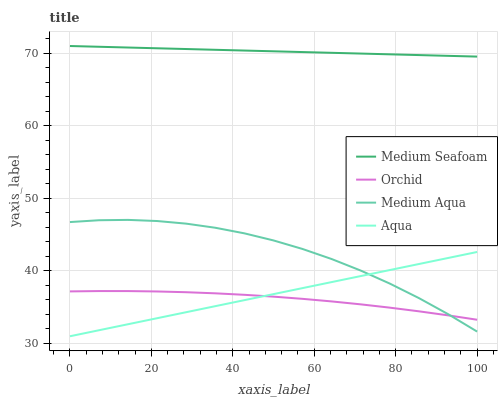Does Orchid have the minimum area under the curve?
Answer yes or no. Yes. Does Medium Seafoam have the maximum area under the curve?
Answer yes or no. Yes. Does Medium Aqua have the minimum area under the curve?
Answer yes or no. No. Does Medium Aqua have the maximum area under the curve?
Answer yes or no. No. Is Aqua the smoothest?
Answer yes or no. Yes. Is Medium Aqua the roughest?
Answer yes or no. Yes. Is Medium Seafoam the smoothest?
Answer yes or no. No. Is Medium Seafoam the roughest?
Answer yes or no. No. Does Aqua have the lowest value?
Answer yes or no. Yes. Does Medium Aqua have the lowest value?
Answer yes or no. No. Does Medium Seafoam have the highest value?
Answer yes or no. Yes. Does Medium Aqua have the highest value?
Answer yes or no. No. Is Aqua less than Medium Seafoam?
Answer yes or no. Yes. Is Medium Seafoam greater than Orchid?
Answer yes or no. Yes. Does Orchid intersect Aqua?
Answer yes or no. Yes. Is Orchid less than Aqua?
Answer yes or no. No. Is Orchid greater than Aqua?
Answer yes or no. No. Does Aqua intersect Medium Seafoam?
Answer yes or no. No. 